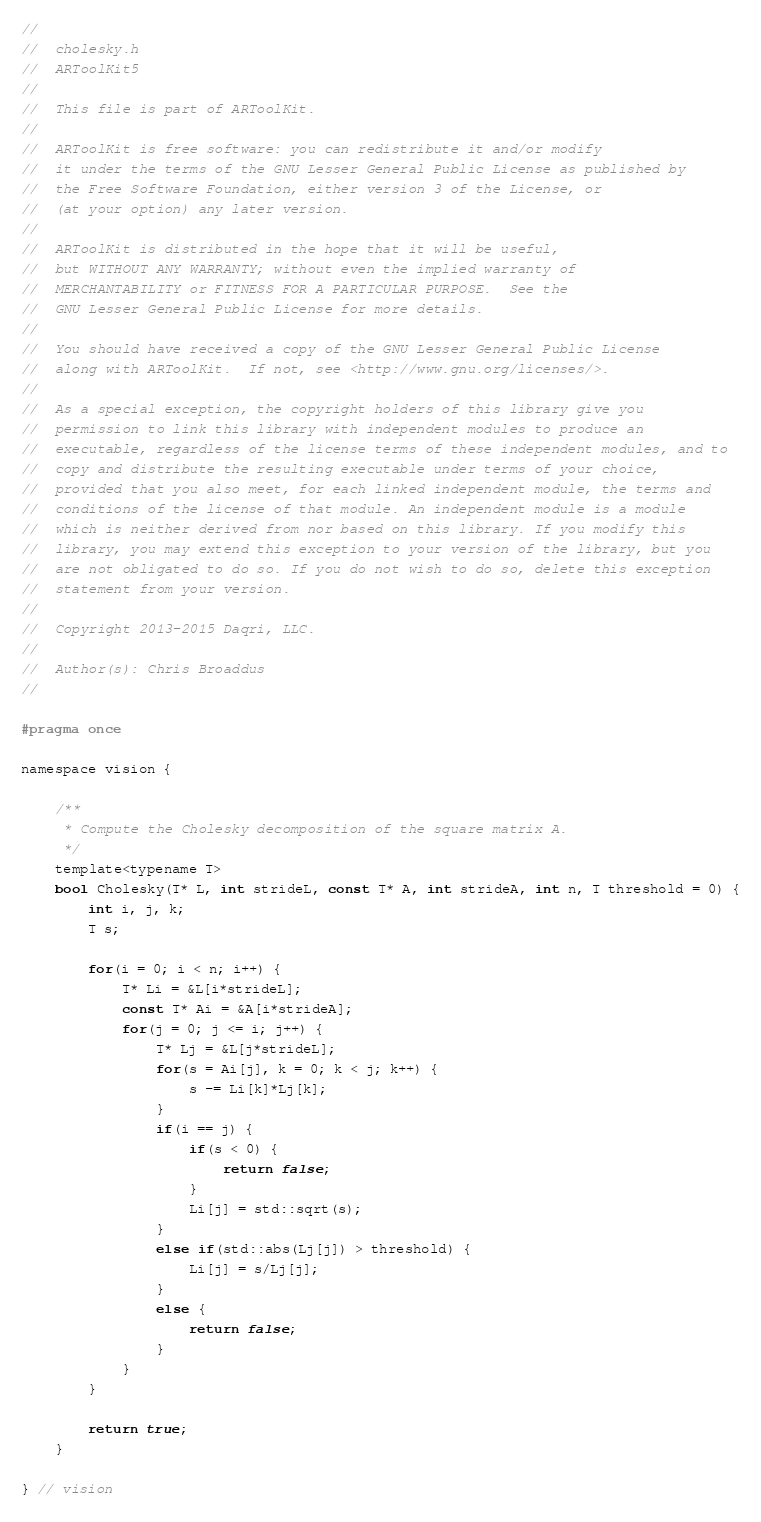<code> <loc_0><loc_0><loc_500><loc_500><_C_>//
//  cholesky.h
//  ARToolKit5
//
//  This file is part of ARToolKit.
//
//  ARToolKit is free software: you can redistribute it and/or modify
//  it under the terms of the GNU Lesser General Public License as published by
//  the Free Software Foundation, either version 3 of the License, or
//  (at your option) any later version.
//
//  ARToolKit is distributed in the hope that it will be useful,
//  but WITHOUT ANY WARRANTY; without even the implied warranty of
//  MERCHANTABILITY or FITNESS FOR A PARTICULAR PURPOSE.  See the
//  GNU Lesser General Public License for more details.
//
//  You should have received a copy of the GNU Lesser General Public License
//  along with ARToolKit.  If not, see <http://www.gnu.org/licenses/>.
//
//  As a special exception, the copyright holders of this library give you
//  permission to link this library with independent modules to produce an
//  executable, regardless of the license terms of these independent modules, and to
//  copy and distribute the resulting executable under terms of your choice,
//  provided that you also meet, for each linked independent module, the terms and
//  conditions of the license of that module. An independent module is a module
//  which is neither derived from nor based on this library. If you modify this
//  library, you may extend this exception to your version of the library, but you
//  are not obligated to do so. If you do not wish to do so, delete this exception
//  statement from your version.
//
//  Copyright 2013-2015 Daqri, LLC.
//
//  Author(s): Chris Broaddus
//

#pragma once

namespace vision {

    /**
     * Compute the Cholesky decomposition of the square matrix A.
     */
    template<typename T>
    bool Cholesky(T* L, int strideL, const T* A, int strideA, int n, T threshold = 0) {
        int i, j, k;
        T s;
        
        for(i = 0; i < n; i++) {
            T* Li = &L[i*strideL];
            const T* Ai = &A[i*strideA];
            for(j = 0; j <= i; j++) {
                T* Lj = &L[j*strideL];
                for(s = Ai[j], k = 0; k < j; k++) {
                    s -= Li[k]*Lj[k];
                }
                if(i == j) {
                    if(s < 0) {
                        return false;
                    }
                    Li[j] = std::sqrt(s);
                }
                else if(std::abs(Lj[j]) > threshold) {
                    Li[j] = s/Lj[j];
                }
                else {
                    return false;
                }
            }
        }
        
        return true;
    }
    
} // vision</code> 